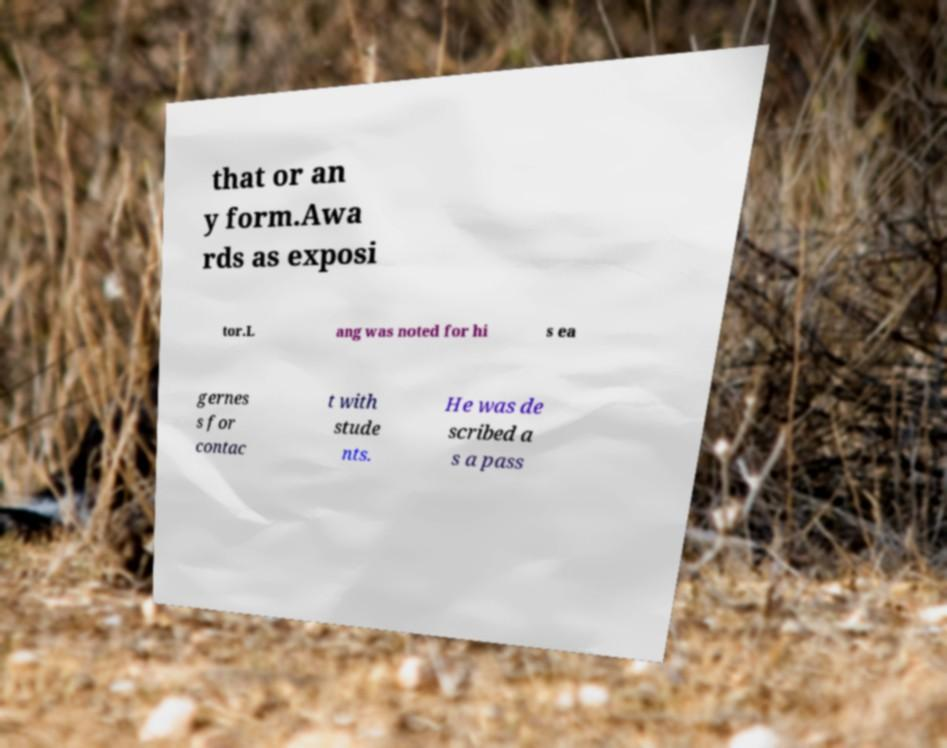I need the written content from this picture converted into text. Can you do that? that or an y form.Awa rds as exposi tor.L ang was noted for hi s ea gernes s for contac t with stude nts. He was de scribed a s a pass 